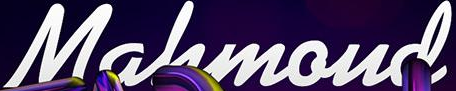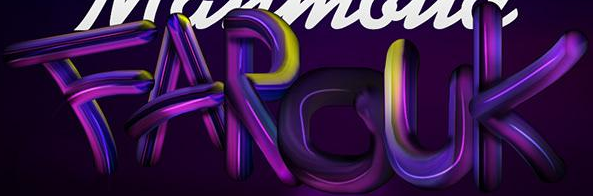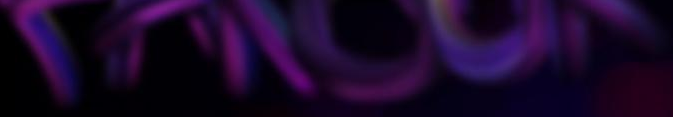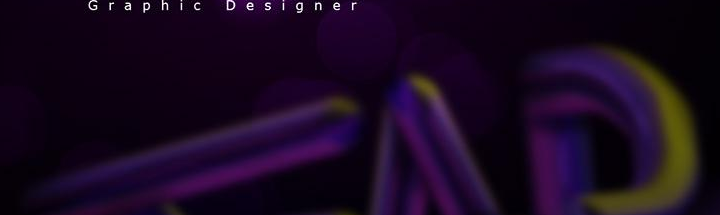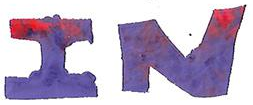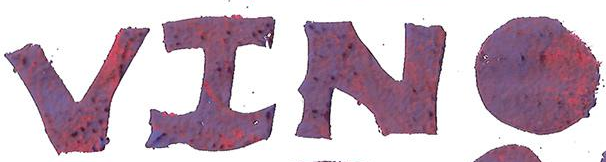What words can you see in these images in sequence, separated by a semicolon? Mahmoud; FAROUK; ######; ###; IN; VINO 